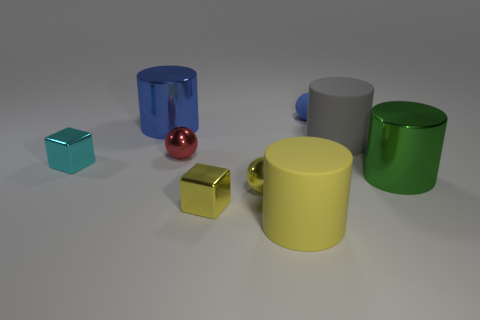Is the color of the tiny matte object the same as the large metal object that is behind the green metal thing?
Your answer should be very brief. Yes. What is the shape of the big metallic thing that is the same color as the tiny matte sphere?
Keep it short and to the point. Cylinder. What shape is the big gray matte thing?
Keep it short and to the point. Cylinder. What number of things are either small spheres that are on the left side of the large yellow cylinder or small cyan cubes?
Your answer should be compact. 3. What size is the blue cylinder that is made of the same material as the tiny cyan block?
Keep it short and to the point. Large. Are there more small yellow things that are behind the small yellow metallic cube than large yellow rubber cylinders?
Ensure brevity in your answer.  No. Do the red thing and the small thing that is behind the gray cylinder have the same shape?
Provide a short and direct response. Yes. What number of large things are green blocks or green metal things?
Your answer should be compact. 1. What size is the metal object that is the same color as the tiny matte object?
Provide a succinct answer. Large. What color is the tiny ball on the right side of the rubber cylinder in front of the tiny yellow metallic cube?
Give a very brief answer. Blue. 